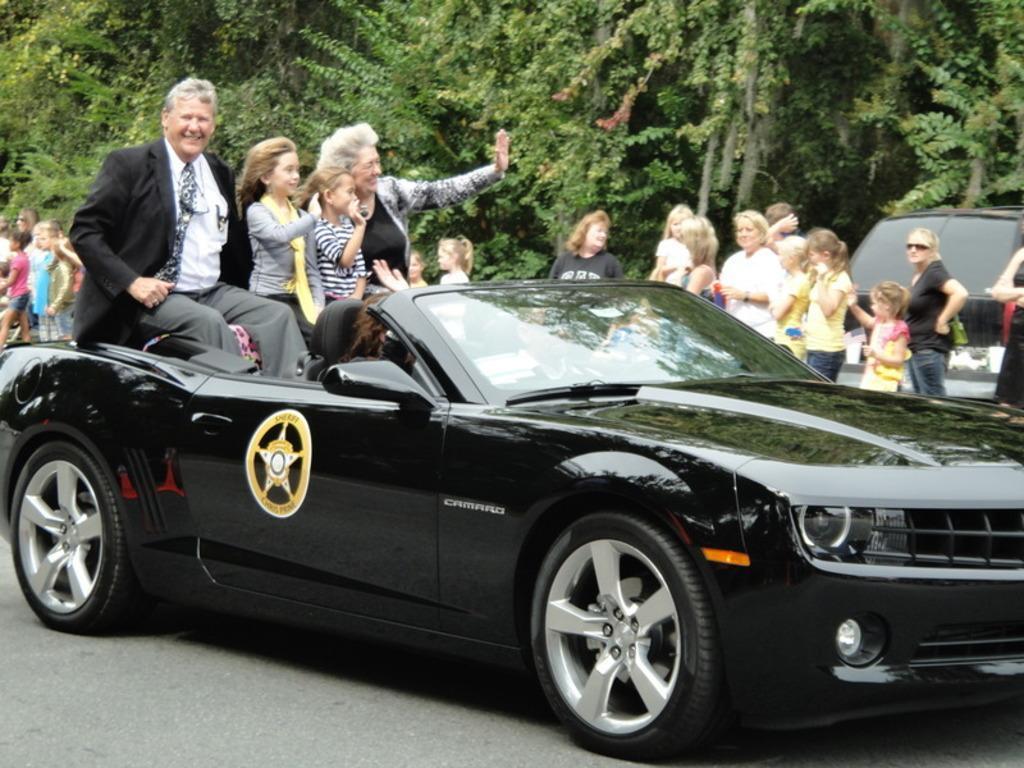Can you describe this image briefly? In this image I can see a car and few people in it. In the background I can see few more people and a vehicle. Here I can see number of trees. I can also see smile on few faces. 